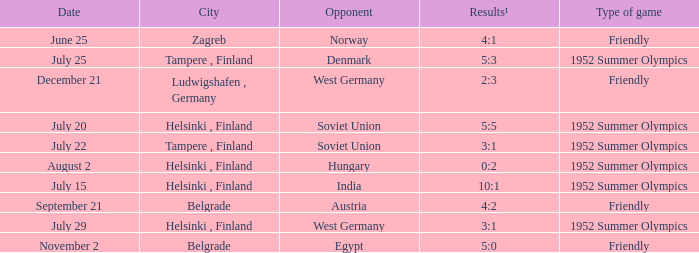With the Type is game of friendly and the City Belgrade and November 2 as the Date what were the Results¹? 5:0. 